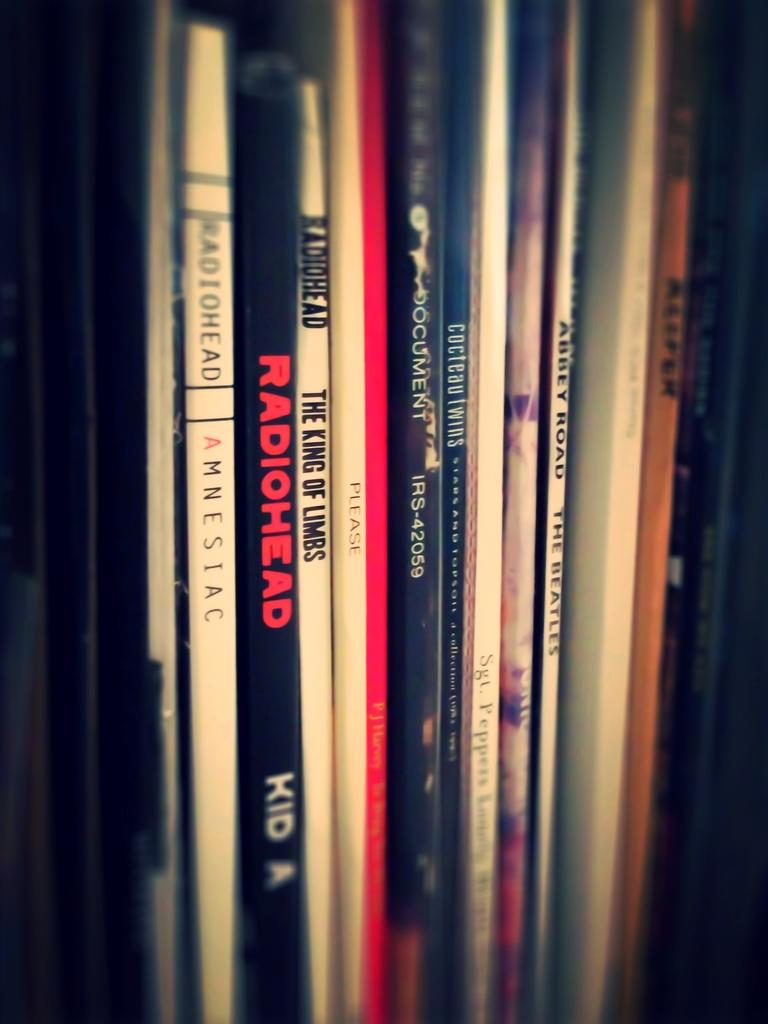<image>
Write a terse but informative summary of the picture. Several records including Radiohead Kid A and The Beatles. 